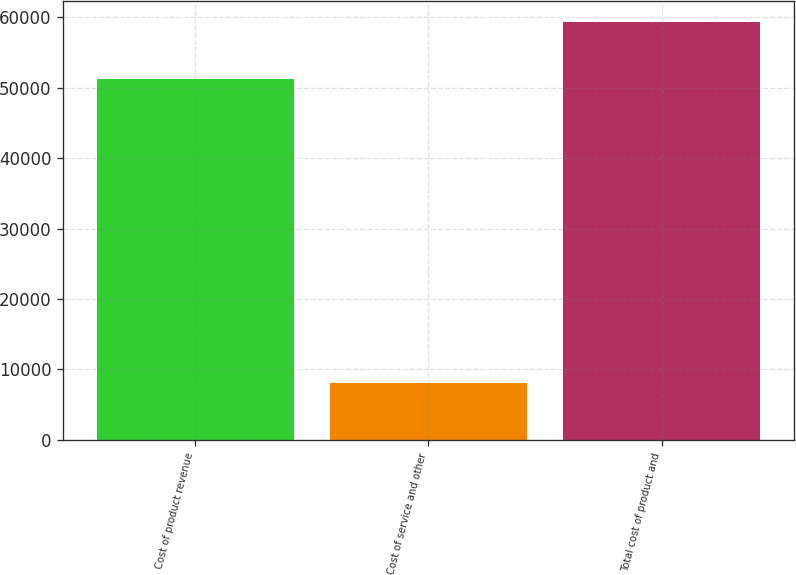<chart> <loc_0><loc_0><loc_500><loc_500><bar_chart><fcel>Cost of product revenue<fcel>Cost of service and other<fcel>Total cost of product and<nl><fcel>51271<fcel>8073<fcel>59344<nl></chart> 